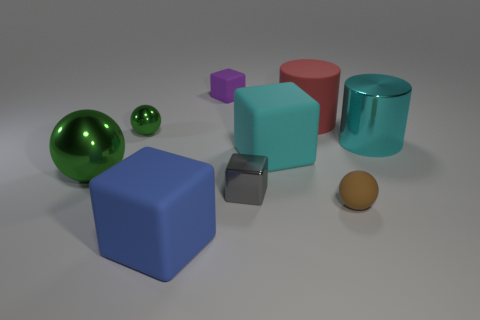What is the size of the metal object that is behind the cyan thing right of the ball that is in front of the gray cube?
Offer a terse response. Small. What size is the matte object that is both left of the small gray thing and in front of the cyan matte cube?
Ensure brevity in your answer.  Large. What is the shape of the green shiny object that is behind the green ball in front of the small green metallic object?
Make the answer very short. Sphere. Are there any other things that are the same color as the shiny cylinder?
Your answer should be compact. Yes. There is a tiny thing right of the red thing; what is its shape?
Ensure brevity in your answer.  Sphere. There is a thing that is both right of the cyan cube and behind the tiny metallic sphere; what shape is it?
Ensure brevity in your answer.  Cylinder. What number of red things are tiny metal cubes or large things?
Keep it short and to the point. 1. Is the color of the tiny matte object in front of the large metallic cylinder the same as the small matte block?
Ensure brevity in your answer.  No. There is a ball to the right of the large rubber cube in front of the brown matte thing; how big is it?
Your answer should be very brief. Small. There is a cyan block that is the same size as the blue block; what material is it?
Keep it short and to the point. Rubber. 